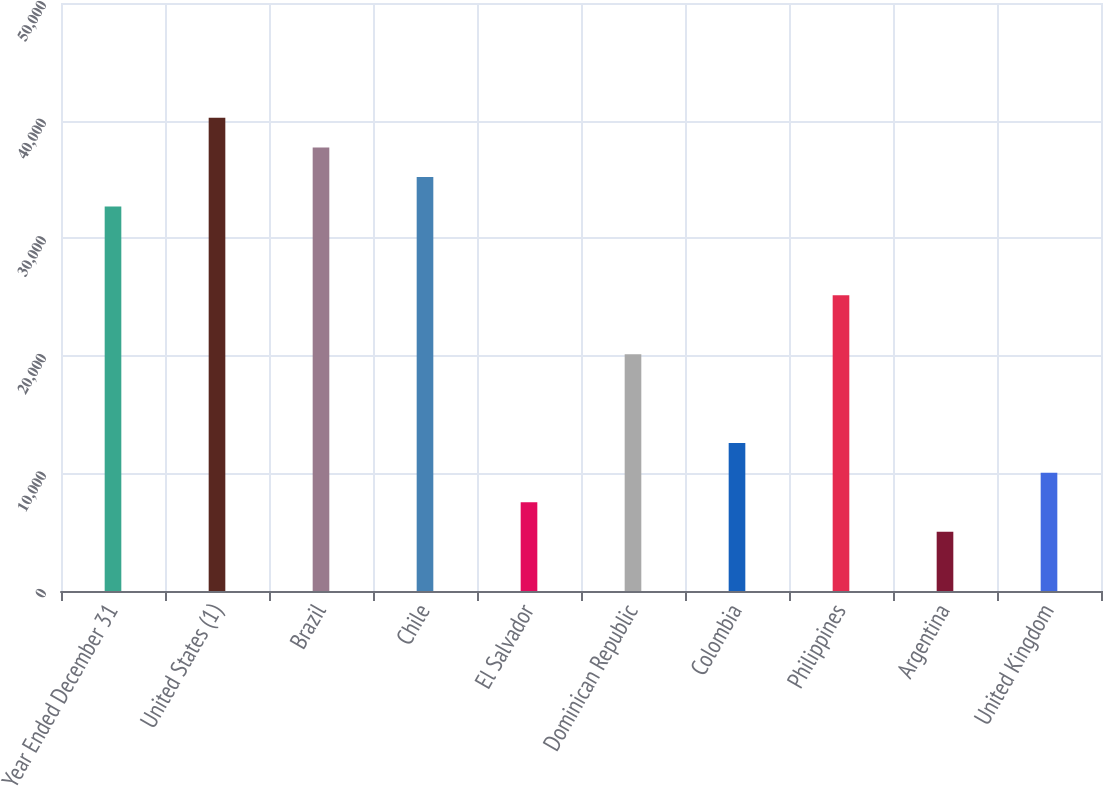<chart> <loc_0><loc_0><loc_500><loc_500><bar_chart><fcel>Year Ended December 31<fcel>United States (1)<fcel>Brazil<fcel>Chile<fcel>El Salvador<fcel>Dominican Republic<fcel>Colombia<fcel>Philippines<fcel>Argentina<fcel>United Kingdom<nl><fcel>32693.9<fcel>40236.8<fcel>37722.5<fcel>35208.2<fcel>7550.9<fcel>20122.4<fcel>12579.5<fcel>25151<fcel>5036.6<fcel>10065.2<nl></chart> 